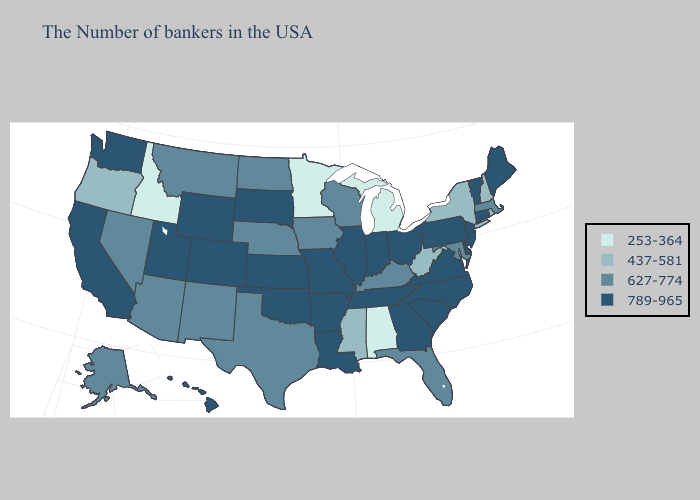Name the states that have a value in the range 627-774?
Quick response, please. Massachusetts, Maryland, Florida, Kentucky, Wisconsin, Iowa, Nebraska, Texas, North Dakota, New Mexico, Montana, Arizona, Nevada, Alaska. Name the states that have a value in the range 627-774?
Write a very short answer. Massachusetts, Maryland, Florida, Kentucky, Wisconsin, Iowa, Nebraska, Texas, North Dakota, New Mexico, Montana, Arizona, Nevada, Alaska. Does Rhode Island have the highest value in the Northeast?
Concise answer only. No. What is the lowest value in states that border Tennessee?
Short answer required. 253-364. What is the value of Virginia?
Be succinct. 789-965. What is the value of Hawaii?
Quick response, please. 789-965. Among the states that border Indiana , which have the highest value?
Answer briefly. Ohio, Illinois. How many symbols are there in the legend?
Keep it brief. 4. Name the states that have a value in the range 627-774?
Answer briefly. Massachusetts, Maryland, Florida, Kentucky, Wisconsin, Iowa, Nebraska, Texas, North Dakota, New Mexico, Montana, Arizona, Nevada, Alaska. What is the value of Delaware?
Give a very brief answer. 789-965. Does Ohio have a lower value than Florida?
Keep it brief. No. What is the lowest value in the MidWest?
Concise answer only. 253-364. Name the states that have a value in the range 253-364?
Concise answer only. Michigan, Alabama, Minnesota, Idaho. What is the highest value in the MidWest ?
Be succinct. 789-965. 